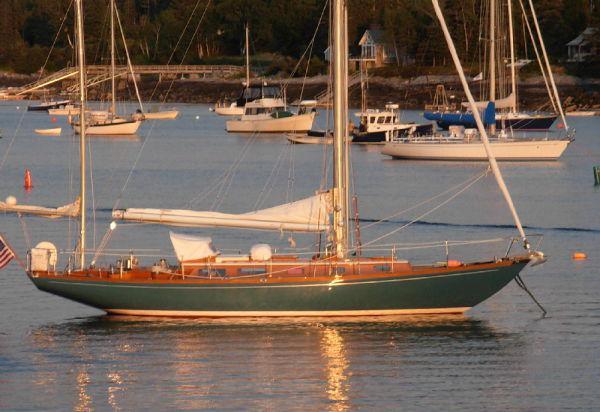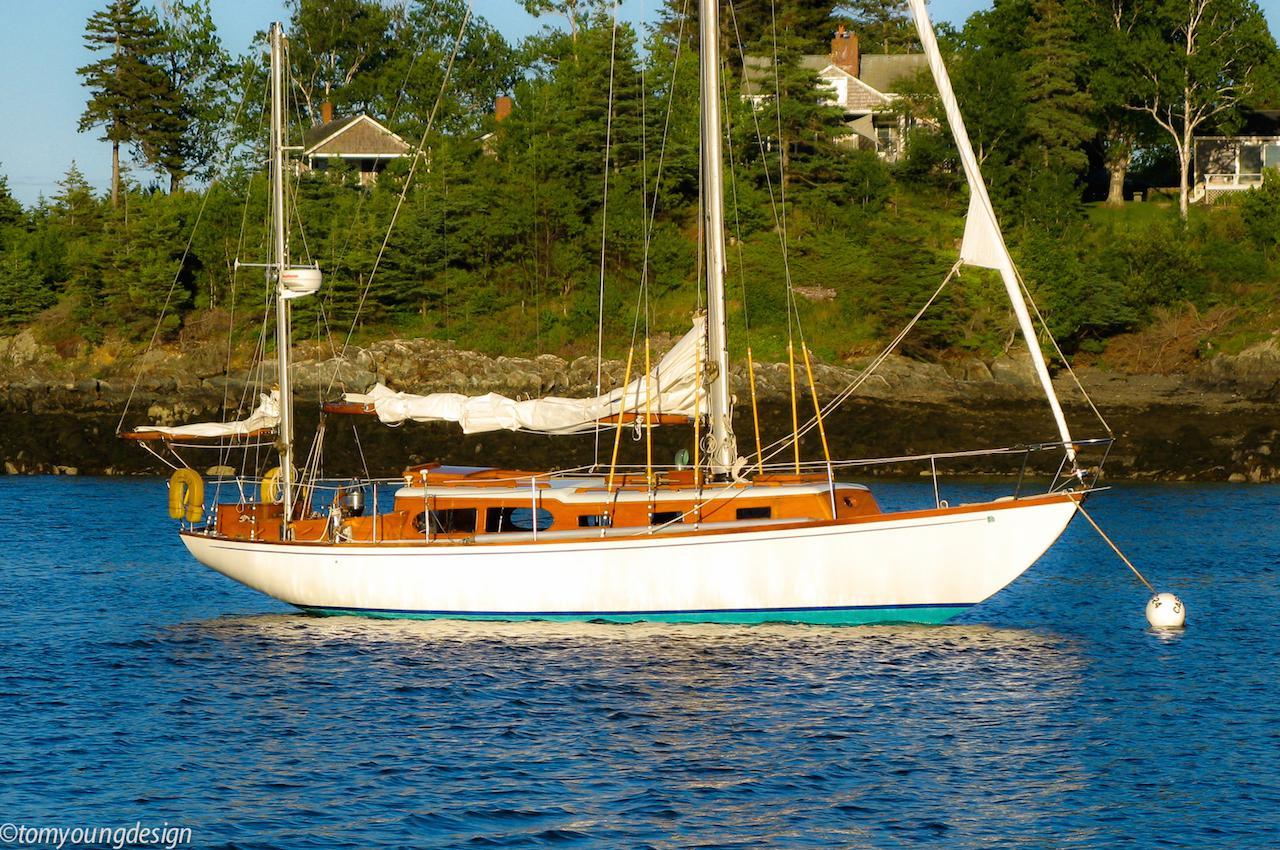The first image is the image on the left, the second image is the image on the right. Given the left and right images, does the statement "Boats are parked by a wooden pier." hold true? Answer yes or no. No. The first image is the image on the left, the second image is the image on the right. Considering the images on both sides, is "An image shows a line of boats with unfurled sails moored alongside a dock." valid? Answer yes or no. No. 